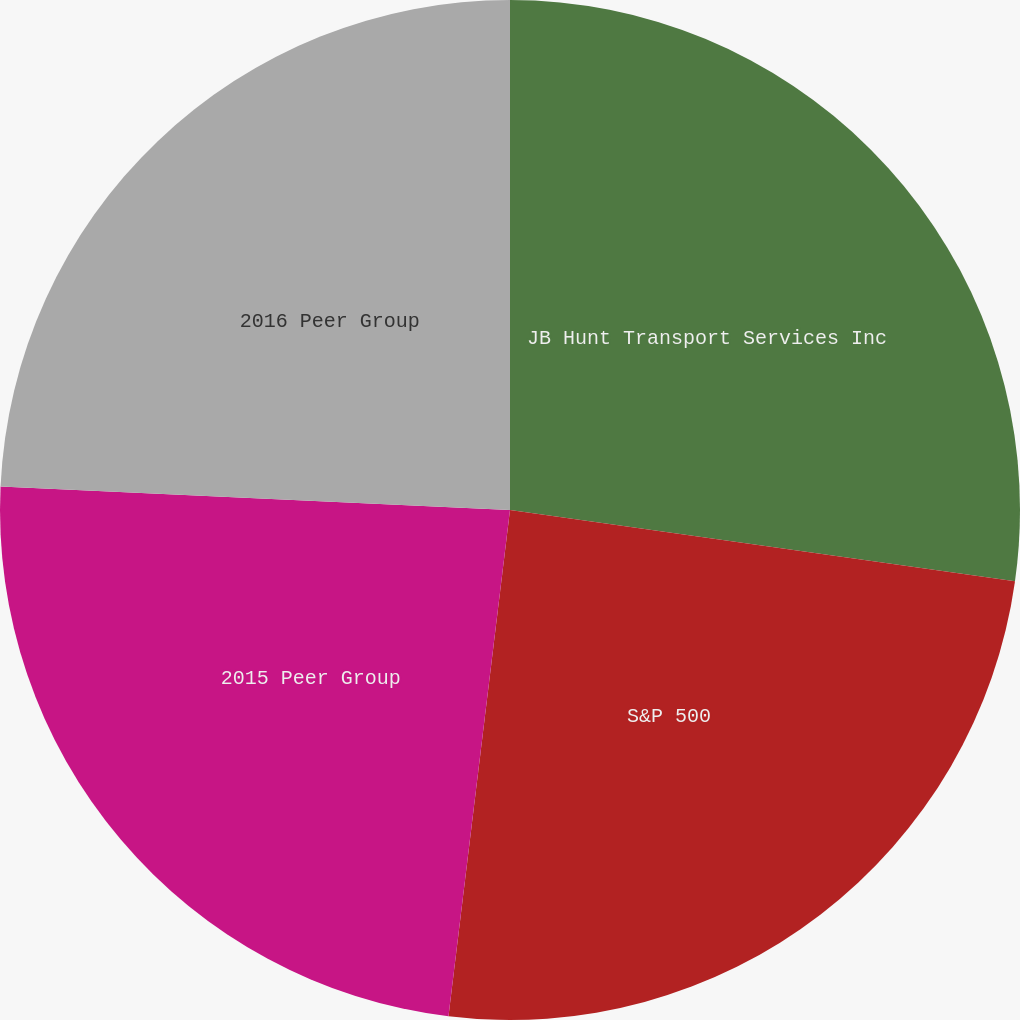<chart> <loc_0><loc_0><loc_500><loc_500><pie_chart><fcel>JB Hunt Transport Services Inc<fcel>S&P 500<fcel>2015 Peer Group<fcel>2016 Peer Group<nl><fcel>27.23%<fcel>24.7%<fcel>23.81%<fcel>24.27%<nl></chart> 